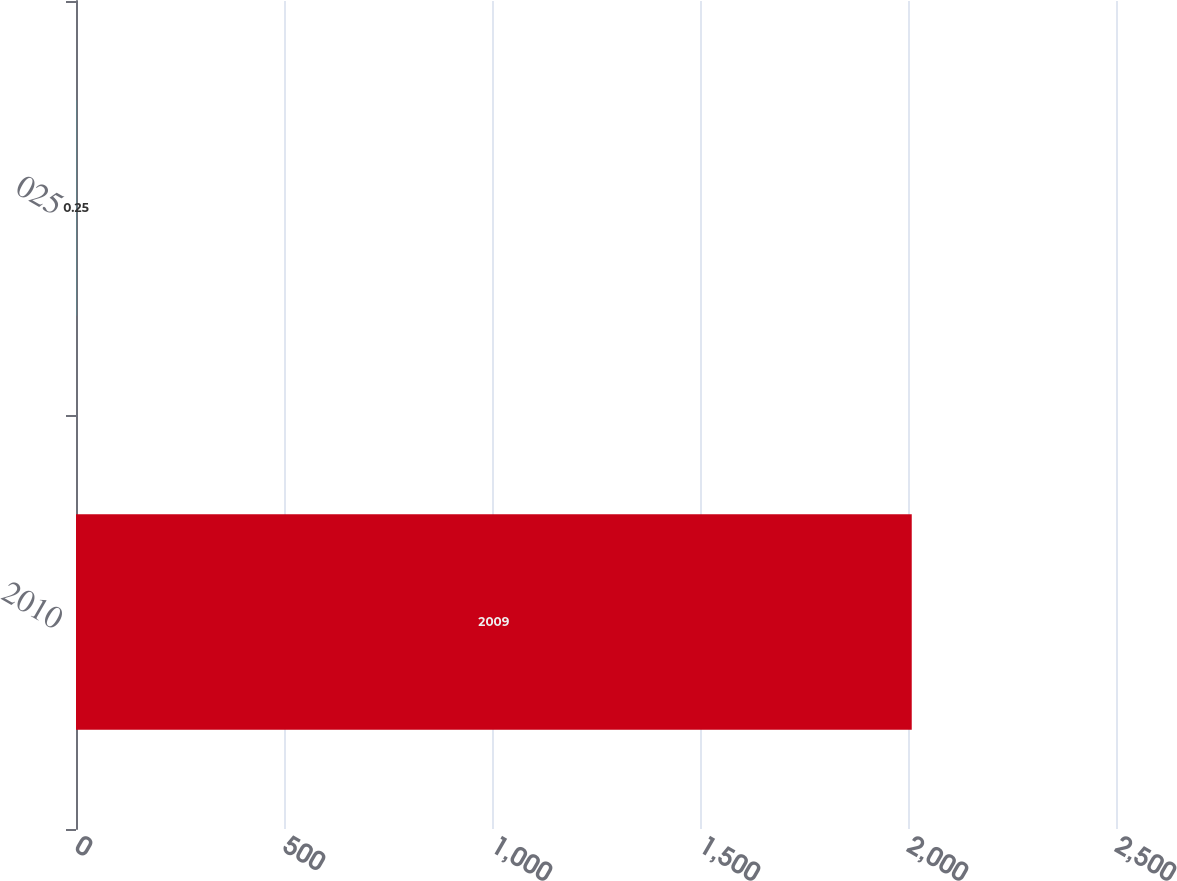Convert chart to OTSL. <chart><loc_0><loc_0><loc_500><loc_500><bar_chart><fcel>2010<fcel>025<nl><fcel>2009<fcel>0.25<nl></chart> 